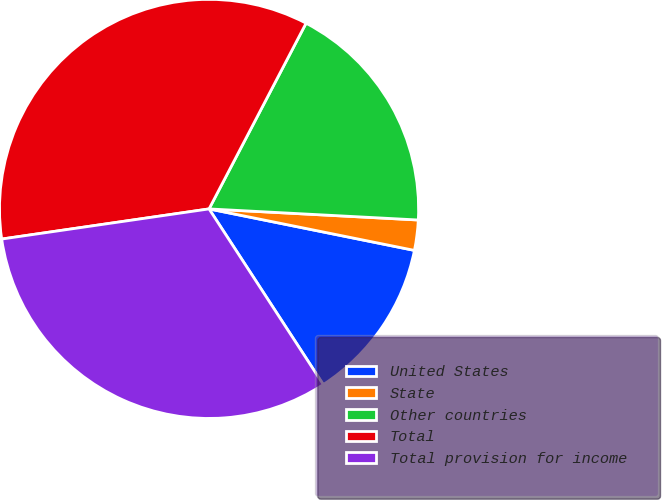Convert chart. <chart><loc_0><loc_0><loc_500><loc_500><pie_chart><fcel>United States<fcel>State<fcel>Other countries<fcel>Total<fcel>Total provision for income<nl><fcel>12.65%<fcel>2.33%<fcel>18.18%<fcel>34.96%<fcel>31.88%<nl></chart> 